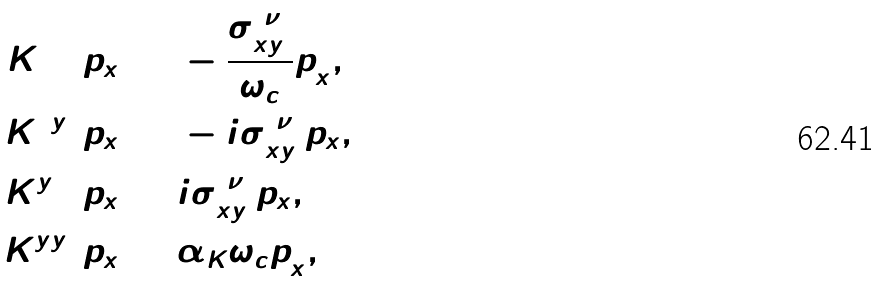Convert formula to latex. <formula><loc_0><loc_0><loc_500><loc_500>K ^ { 0 0 } _ { 0 } ( p _ { x } ) = & - \frac { \sigma ^ { ( \nu ) } _ { x y } } { \omega _ { c } } p ^ { 2 } _ { x } , \\ K ^ { 0 y } _ { 0 } ( p _ { x } ) = & - i \sigma ^ { ( \nu ) } _ { x y } p _ { x } , \\ K ^ { y 0 } _ { 0 } ( p _ { x } ) = & i \sigma ^ { ( \nu ) } _ { x y } p _ { x } , \\ K ^ { y y } _ { 0 } ( p _ { x } ) = & \alpha _ { K } \omega _ { c } p ^ { 2 } _ { x } ,</formula> 